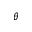<formula> <loc_0><loc_0><loc_500><loc_500>\theta</formula> 